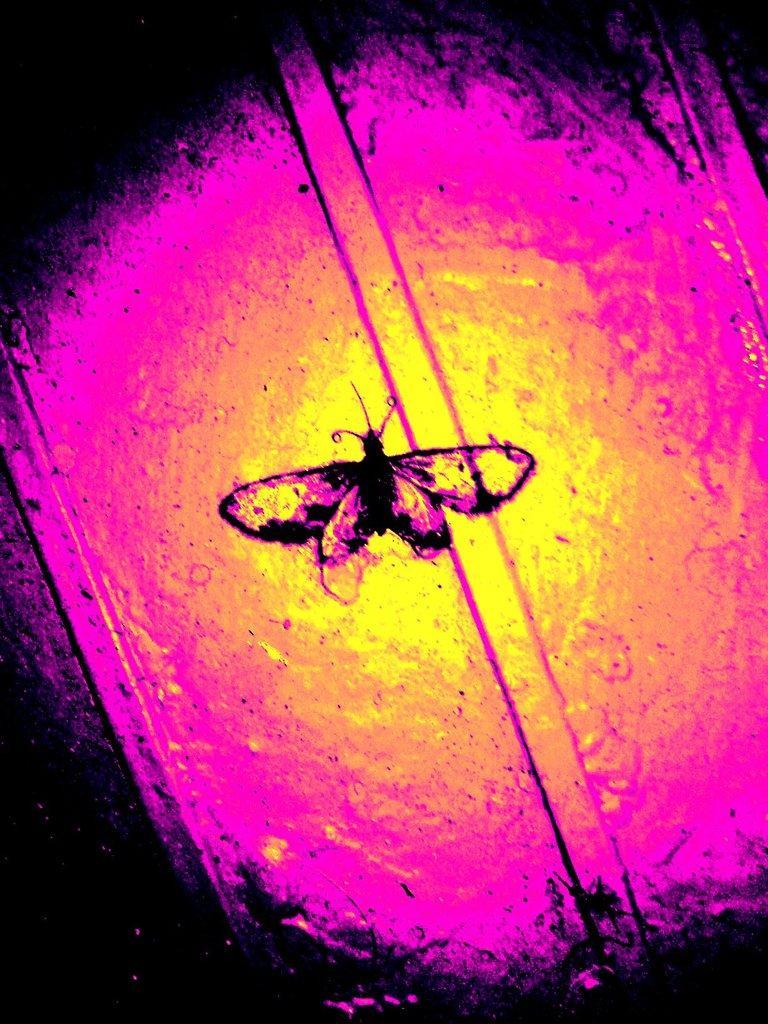Describe this image in one or two sentences. In the picture there is an insect and around the insect there are multiple colors of surfaces. 